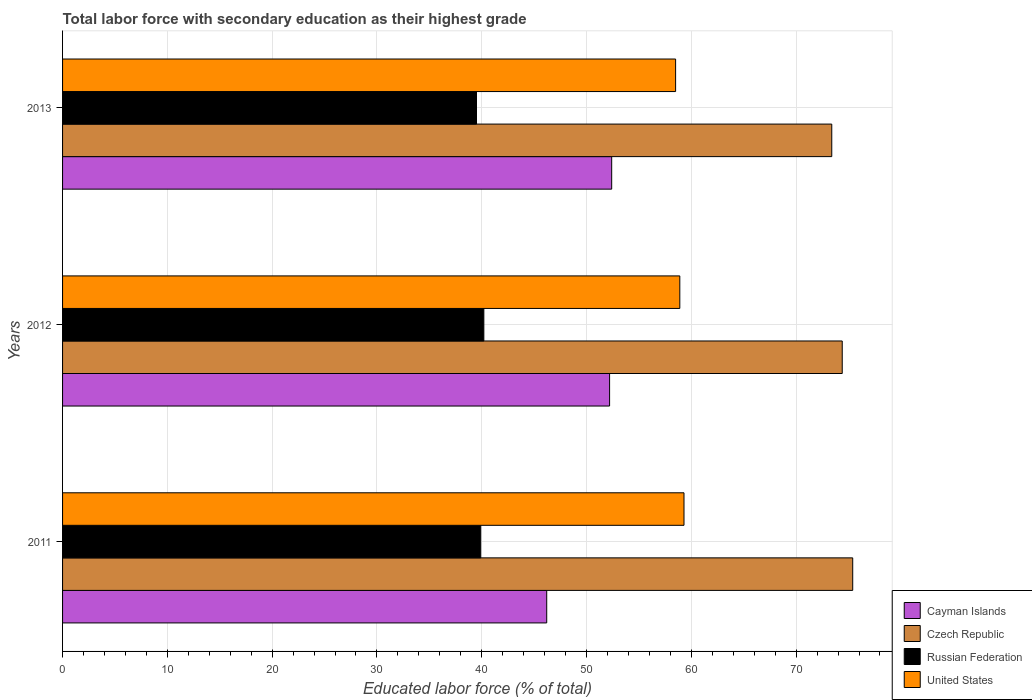How many different coloured bars are there?
Your answer should be compact. 4. How many groups of bars are there?
Your response must be concise. 3. Are the number of bars on each tick of the Y-axis equal?
Provide a short and direct response. Yes. What is the percentage of total labor force with primary education in United States in 2013?
Offer a terse response. 58.5. Across all years, what is the maximum percentage of total labor force with primary education in Cayman Islands?
Provide a succinct answer. 52.4. Across all years, what is the minimum percentage of total labor force with primary education in Czech Republic?
Provide a short and direct response. 73.4. What is the total percentage of total labor force with primary education in United States in the graph?
Keep it short and to the point. 176.7. What is the difference between the percentage of total labor force with primary education in United States in 2012 and that in 2013?
Offer a very short reply. 0.4. What is the difference between the percentage of total labor force with primary education in United States in 2013 and the percentage of total labor force with primary education in Russian Federation in 2012?
Offer a very short reply. 18.3. What is the average percentage of total labor force with primary education in Cayman Islands per year?
Offer a very short reply. 50.27. In the year 2013, what is the difference between the percentage of total labor force with primary education in United States and percentage of total labor force with primary education in Russian Federation?
Your answer should be very brief. 19. In how many years, is the percentage of total labor force with primary education in United States greater than 24 %?
Provide a short and direct response. 3. What is the ratio of the percentage of total labor force with primary education in Czech Republic in 2011 to that in 2013?
Make the answer very short. 1.03. Is the percentage of total labor force with primary education in Russian Federation in 2012 less than that in 2013?
Provide a short and direct response. No. Is the difference between the percentage of total labor force with primary education in United States in 2011 and 2013 greater than the difference between the percentage of total labor force with primary education in Russian Federation in 2011 and 2013?
Provide a short and direct response. Yes. What is the difference between the highest and the second highest percentage of total labor force with primary education in United States?
Provide a succinct answer. 0.4. What is the difference between the highest and the lowest percentage of total labor force with primary education in United States?
Keep it short and to the point. 0.8. In how many years, is the percentage of total labor force with primary education in Russian Federation greater than the average percentage of total labor force with primary education in Russian Federation taken over all years?
Keep it short and to the point. 2. Is the sum of the percentage of total labor force with primary education in Czech Republic in 2012 and 2013 greater than the maximum percentage of total labor force with primary education in Russian Federation across all years?
Your response must be concise. Yes. Is it the case that in every year, the sum of the percentage of total labor force with primary education in Czech Republic and percentage of total labor force with primary education in Russian Federation is greater than the sum of percentage of total labor force with primary education in United States and percentage of total labor force with primary education in Cayman Islands?
Your answer should be very brief. Yes. What does the 1st bar from the top in 2011 represents?
Your answer should be very brief. United States. What does the 2nd bar from the bottom in 2013 represents?
Keep it short and to the point. Czech Republic. Is it the case that in every year, the sum of the percentage of total labor force with primary education in Cayman Islands and percentage of total labor force with primary education in Russian Federation is greater than the percentage of total labor force with primary education in United States?
Provide a succinct answer. Yes. Where does the legend appear in the graph?
Keep it short and to the point. Bottom right. What is the title of the graph?
Give a very brief answer. Total labor force with secondary education as their highest grade. What is the label or title of the X-axis?
Your answer should be very brief. Educated labor force (% of total). What is the Educated labor force (% of total) of Cayman Islands in 2011?
Ensure brevity in your answer.  46.2. What is the Educated labor force (% of total) in Czech Republic in 2011?
Offer a very short reply. 75.4. What is the Educated labor force (% of total) of Russian Federation in 2011?
Your answer should be very brief. 39.9. What is the Educated labor force (% of total) in United States in 2011?
Make the answer very short. 59.3. What is the Educated labor force (% of total) of Cayman Islands in 2012?
Give a very brief answer. 52.2. What is the Educated labor force (% of total) of Czech Republic in 2012?
Provide a short and direct response. 74.4. What is the Educated labor force (% of total) in Russian Federation in 2012?
Provide a succinct answer. 40.2. What is the Educated labor force (% of total) of United States in 2012?
Give a very brief answer. 58.9. What is the Educated labor force (% of total) in Cayman Islands in 2013?
Make the answer very short. 52.4. What is the Educated labor force (% of total) in Czech Republic in 2013?
Ensure brevity in your answer.  73.4. What is the Educated labor force (% of total) of Russian Federation in 2013?
Keep it short and to the point. 39.5. What is the Educated labor force (% of total) in United States in 2013?
Make the answer very short. 58.5. Across all years, what is the maximum Educated labor force (% of total) of Cayman Islands?
Your response must be concise. 52.4. Across all years, what is the maximum Educated labor force (% of total) in Czech Republic?
Your answer should be compact. 75.4. Across all years, what is the maximum Educated labor force (% of total) in Russian Federation?
Your answer should be very brief. 40.2. Across all years, what is the maximum Educated labor force (% of total) of United States?
Offer a terse response. 59.3. Across all years, what is the minimum Educated labor force (% of total) of Cayman Islands?
Give a very brief answer. 46.2. Across all years, what is the minimum Educated labor force (% of total) in Czech Republic?
Your response must be concise. 73.4. Across all years, what is the minimum Educated labor force (% of total) of Russian Federation?
Your response must be concise. 39.5. Across all years, what is the minimum Educated labor force (% of total) in United States?
Offer a terse response. 58.5. What is the total Educated labor force (% of total) of Cayman Islands in the graph?
Provide a short and direct response. 150.8. What is the total Educated labor force (% of total) of Czech Republic in the graph?
Your response must be concise. 223.2. What is the total Educated labor force (% of total) in Russian Federation in the graph?
Make the answer very short. 119.6. What is the total Educated labor force (% of total) of United States in the graph?
Make the answer very short. 176.7. What is the difference between the Educated labor force (% of total) of Cayman Islands in 2011 and that in 2012?
Make the answer very short. -6. What is the difference between the Educated labor force (% of total) in Czech Republic in 2011 and that in 2012?
Your response must be concise. 1. What is the difference between the Educated labor force (% of total) in Russian Federation in 2011 and that in 2012?
Provide a succinct answer. -0.3. What is the difference between the Educated labor force (% of total) of Cayman Islands in 2011 and the Educated labor force (% of total) of Czech Republic in 2012?
Provide a short and direct response. -28.2. What is the difference between the Educated labor force (% of total) of Czech Republic in 2011 and the Educated labor force (% of total) of Russian Federation in 2012?
Give a very brief answer. 35.2. What is the difference between the Educated labor force (% of total) of Czech Republic in 2011 and the Educated labor force (% of total) of United States in 2012?
Provide a short and direct response. 16.5. What is the difference between the Educated labor force (% of total) in Cayman Islands in 2011 and the Educated labor force (% of total) in Czech Republic in 2013?
Your answer should be compact. -27.2. What is the difference between the Educated labor force (% of total) of Cayman Islands in 2011 and the Educated labor force (% of total) of Russian Federation in 2013?
Your answer should be compact. 6.7. What is the difference between the Educated labor force (% of total) of Cayman Islands in 2011 and the Educated labor force (% of total) of United States in 2013?
Your response must be concise. -12.3. What is the difference between the Educated labor force (% of total) of Czech Republic in 2011 and the Educated labor force (% of total) of Russian Federation in 2013?
Offer a very short reply. 35.9. What is the difference between the Educated labor force (% of total) of Czech Republic in 2011 and the Educated labor force (% of total) of United States in 2013?
Offer a very short reply. 16.9. What is the difference between the Educated labor force (% of total) of Russian Federation in 2011 and the Educated labor force (% of total) of United States in 2013?
Offer a very short reply. -18.6. What is the difference between the Educated labor force (% of total) in Cayman Islands in 2012 and the Educated labor force (% of total) in Czech Republic in 2013?
Offer a terse response. -21.2. What is the difference between the Educated labor force (% of total) in Czech Republic in 2012 and the Educated labor force (% of total) in Russian Federation in 2013?
Your answer should be compact. 34.9. What is the difference between the Educated labor force (% of total) in Czech Republic in 2012 and the Educated labor force (% of total) in United States in 2013?
Provide a succinct answer. 15.9. What is the difference between the Educated labor force (% of total) of Russian Federation in 2012 and the Educated labor force (% of total) of United States in 2013?
Offer a terse response. -18.3. What is the average Educated labor force (% of total) in Cayman Islands per year?
Keep it short and to the point. 50.27. What is the average Educated labor force (% of total) in Czech Republic per year?
Your response must be concise. 74.4. What is the average Educated labor force (% of total) of Russian Federation per year?
Make the answer very short. 39.87. What is the average Educated labor force (% of total) of United States per year?
Offer a very short reply. 58.9. In the year 2011, what is the difference between the Educated labor force (% of total) of Cayman Islands and Educated labor force (% of total) of Czech Republic?
Your response must be concise. -29.2. In the year 2011, what is the difference between the Educated labor force (% of total) in Cayman Islands and Educated labor force (% of total) in Russian Federation?
Give a very brief answer. 6.3. In the year 2011, what is the difference between the Educated labor force (% of total) in Cayman Islands and Educated labor force (% of total) in United States?
Your answer should be very brief. -13.1. In the year 2011, what is the difference between the Educated labor force (% of total) of Czech Republic and Educated labor force (% of total) of Russian Federation?
Keep it short and to the point. 35.5. In the year 2011, what is the difference between the Educated labor force (% of total) in Czech Republic and Educated labor force (% of total) in United States?
Offer a very short reply. 16.1. In the year 2011, what is the difference between the Educated labor force (% of total) of Russian Federation and Educated labor force (% of total) of United States?
Ensure brevity in your answer.  -19.4. In the year 2012, what is the difference between the Educated labor force (% of total) of Cayman Islands and Educated labor force (% of total) of Czech Republic?
Your answer should be very brief. -22.2. In the year 2012, what is the difference between the Educated labor force (% of total) of Czech Republic and Educated labor force (% of total) of Russian Federation?
Provide a short and direct response. 34.2. In the year 2012, what is the difference between the Educated labor force (% of total) of Czech Republic and Educated labor force (% of total) of United States?
Provide a succinct answer. 15.5. In the year 2012, what is the difference between the Educated labor force (% of total) of Russian Federation and Educated labor force (% of total) of United States?
Offer a very short reply. -18.7. In the year 2013, what is the difference between the Educated labor force (% of total) in Cayman Islands and Educated labor force (% of total) in Russian Federation?
Your answer should be very brief. 12.9. In the year 2013, what is the difference between the Educated labor force (% of total) in Cayman Islands and Educated labor force (% of total) in United States?
Provide a short and direct response. -6.1. In the year 2013, what is the difference between the Educated labor force (% of total) of Czech Republic and Educated labor force (% of total) of Russian Federation?
Your response must be concise. 33.9. What is the ratio of the Educated labor force (% of total) of Cayman Islands in 2011 to that in 2012?
Ensure brevity in your answer.  0.89. What is the ratio of the Educated labor force (% of total) in Czech Republic in 2011 to that in 2012?
Your response must be concise. 1.01. What is the ratio of the Educated labor force (% of total) of Russian Federation in 2011 to that in 2012?
Provide a succinct answer. 0.99. What is the ratio of the Educated labor force (% of total) in United States in 2011 to that in 2012?
Keep it short and to the point. 1.01. What is the ratio of the Educated labor force (% of total) of Cayman Islands in 2011 to that in 2013?
Ensure brevity in your answer.  0.88. What is the ratio of the Educated labor force (% of total) in Czech Republic in 2011 to that in 2013?
Keep it short and to the point. 1.03. What is the ratio of the Educated labor force (% of total) of Russian Federation in 2011 to that in 2013?
Provide a succinct answer. 1.01. What is the ratio of the Educated labor force (% of total) in United States in 2011 to that in 2013?
Provide a short and direct response. 1.01. What is the ratio of the Educated labor force (% of total) of Cayman Islands in 2012 to that in 2013?
Ensure brevity in your answer.  1. What is the ratio of the Educated labor force (% of total) of Czech Republic in 2012 to that in 2013?
Keep it short and to the point. 1.01. What is the ratio of the Educated labor force (% of total) in Russian Federation in 2012 to that in 2013?
Ensure brevity in your answer.  1.02. What is the ratio of the Educated labor force (% of total) of United States in 2012 to that in 2013?
Offer a terse response. 1.01. What is the difference between the highest and the second highest Educated labor force (% of total) in Cayman Islands?
Give a very brief answer. 0.2. What is the difference between the highest and the second highest Educated labor force (% of total) of Czech Republic?
Your answer should be compact. 1. What is the difference between the highest and the second highest Educated labor force (% of total) in Russian Federation?
Your answer should be compact. 0.3. What is the difference between the highest and the lowest Educated labor force (% of total) in Cayman Islands?
Provide a short and direct response. 6.2. What is the difference between the highest and the lowest Educated labor force (% of total) in Russian Federation?
Offer a terse response. 0.7. 